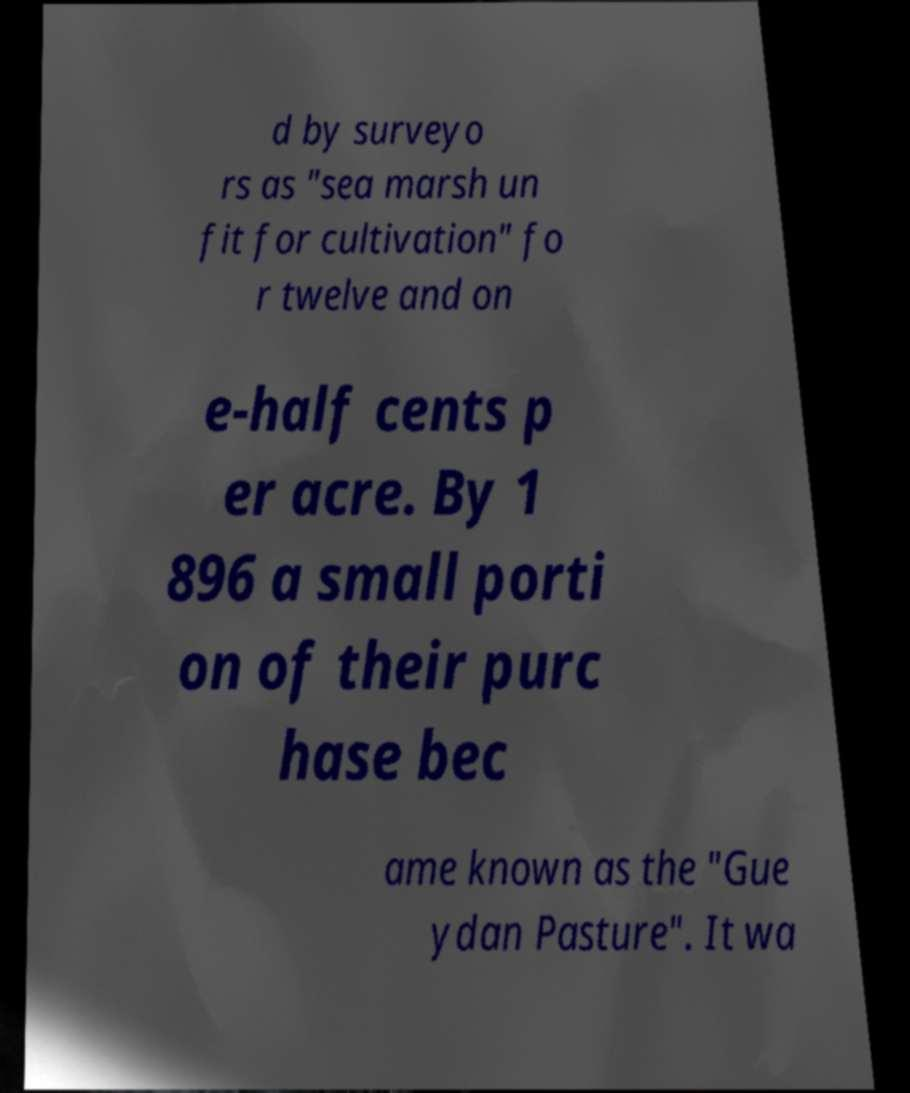What messages or text are displayed in this image? I need them in a readable, typed format. d by surveyo rs as "sea marsh un fit for cultivation" fo r twelve and on e-half cents p er acre. By 1 896 a small porti on of their purc hase bec ame known as the "Gue ydan Pasture". It wa 